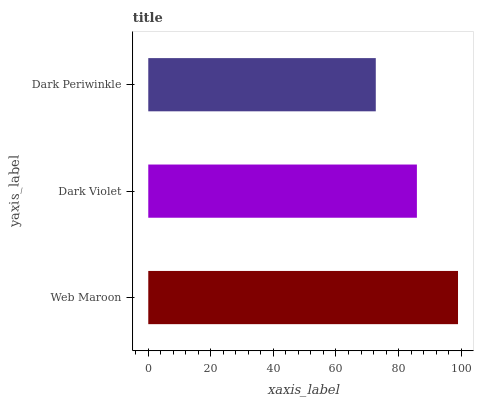Is Dark Periwinkle the minimum?
Answer yes or no. Yes. Is Web Maroon the maximum?
Answer yes or no. Yes. Is Dark Violet the minimum?
Answer yes or no. No. Is Dark Violet the maximum?
Answer yes or no. No. Is Web Maroon greater than Dark Violet?
Answer yes or no. Yes. Is Dark Violet less than Web Maroon?
Answer yes or no. Yes. Is Dark Violet greater than Web Maroon?
Answer yes or no. No. Is Web Maroon less than Dark Violet?
Answer yes or no. No. Is Dark Violet the high median?
Answer yes or no. Yes. Is Dark Violet the low median?
Answer yes or no. Yes. Is Web Maroon the high median?
Answer yes or no. No. Is Web Maroon the low median?
Answer yes or no. No. 